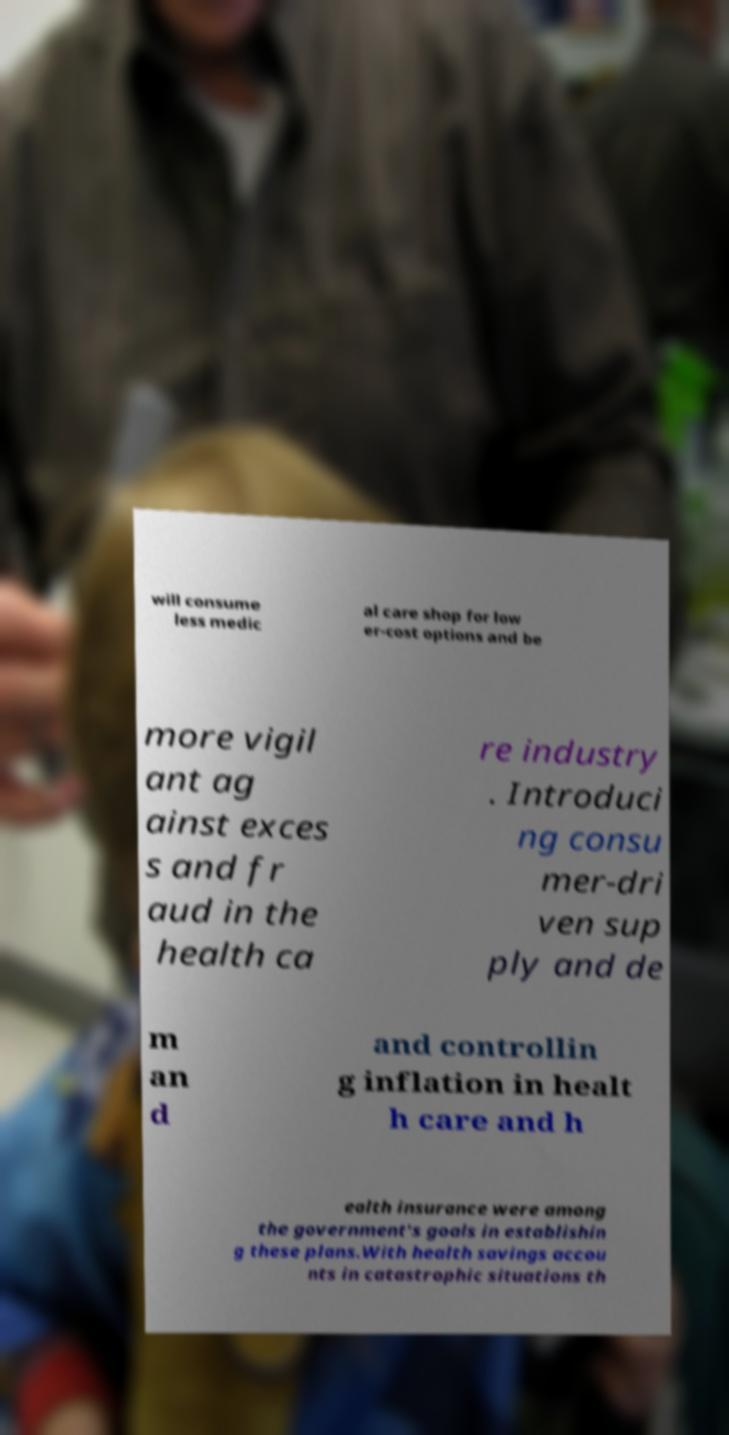There's text embedded in this image that I need extracted. Can you transcribe it verbatim? will consume less medic al care shop for low er-cost options and be more vigil ant ag ainst exces s and fr aud in the health ca re industry . Introduci ng consu mer-dri ven sup ply and de m an d and controllin g inflation in healt h care and h ealth insurance were among the government's goals in establishin g these plans.With health savings accou nts in catastrophic situations th 